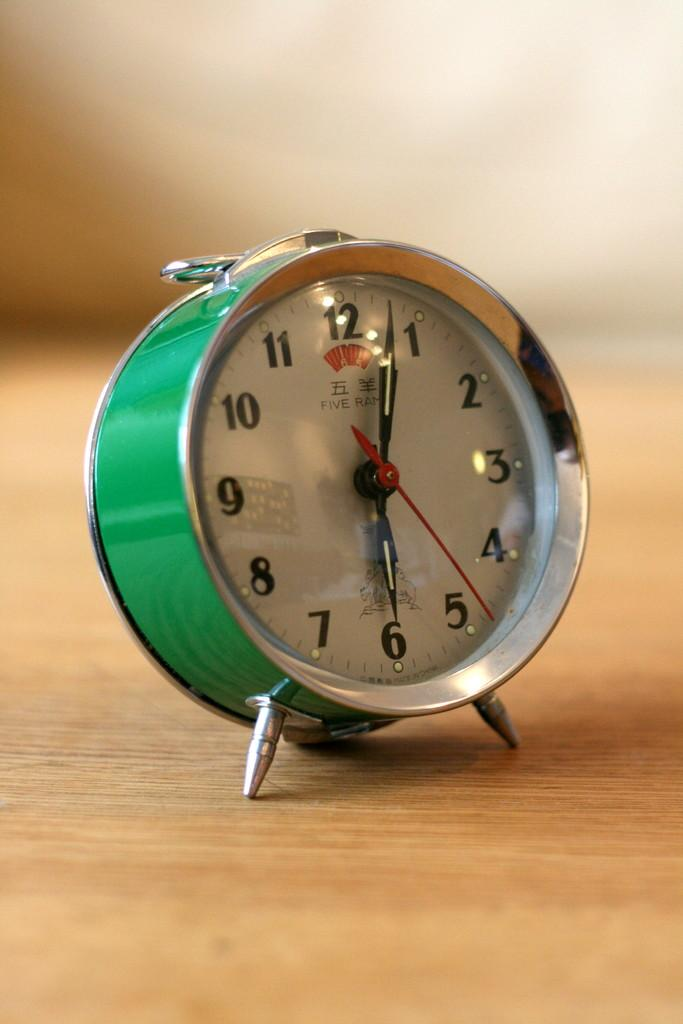What color is the clock in the image? The clock in the image is green. What type of surface is the clock placed on? The clock is on a wooden surface. Can you describe the background of the image? The background of the image is blurred. What is the clock's belief about the current political situation? The clock is an inanimate object and does not have beliefs or thoughts about any political situation. 